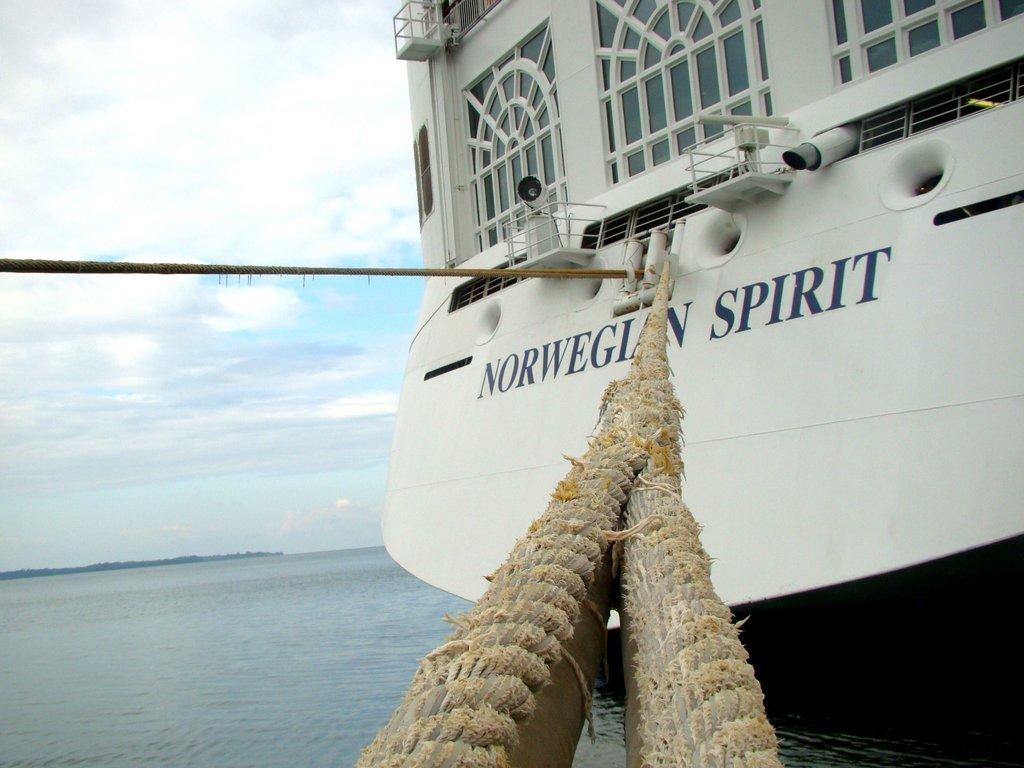Where was the image taken? The image was clicked outside. What is the main subject in the image? There is a boat in the middle of the image. What type of environment is visible in the image? There is water visible at the bottom of the image and the sky is visible at the top of the image. How many beads are hanging from the boat in the image? There are no beads present in the image. What do you believe the boat is used for in the image? The purpose of the boat cannot be determined from the image alone. 